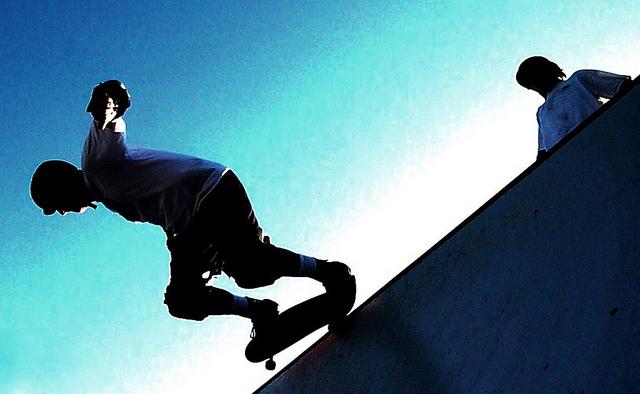What does this person doing?
Give a very brief answer. Skateboarding. How many people are there?
Concise answer only. 2. What is on his left elbow?
Write a very short answer. Pad. 